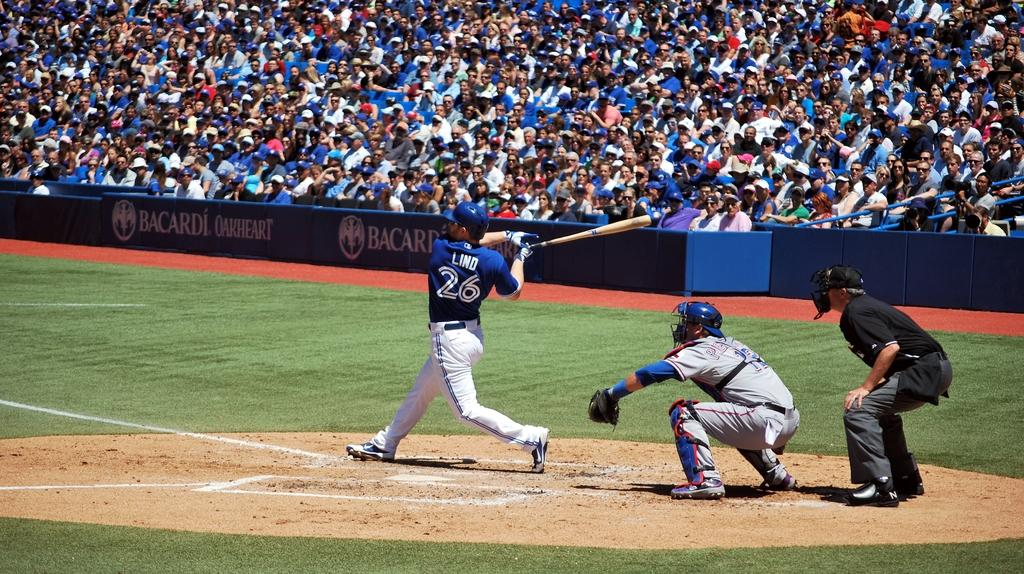Provide a one-sentence caption for the provided image. A batter with the number 26 and word Lind on the back of his shirt is swinging his bat. 